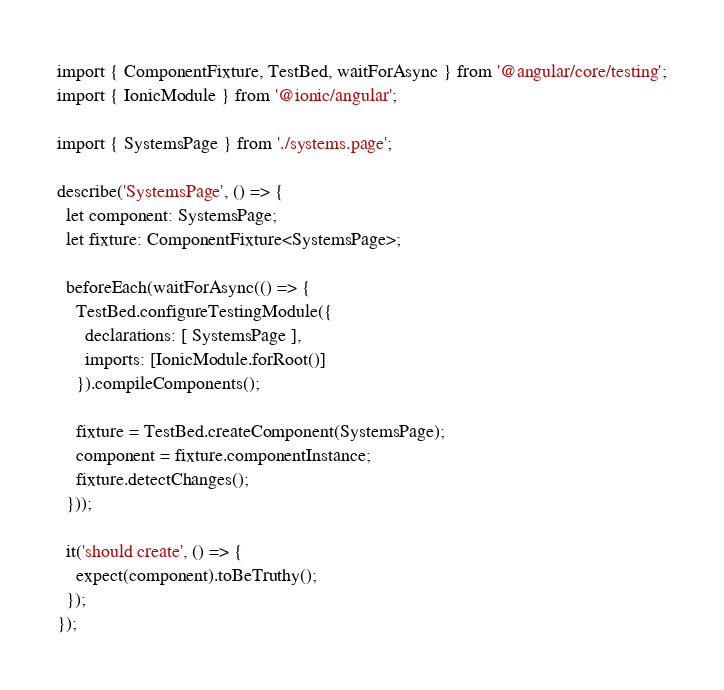Convert code to text. <code><loc_0><loc_0><loc_500><loc_500><_TypeScript_>import { ComponentFixture, TestBed, waitForAsync } from '@angular/core/testing';
import { IonicModule } from '@ionic/angular';

import { SystemsPage } from './systems.page';

describe('SystemsPage', () => {
  let component: SystemsPage;
  let fixture: ComponentFixture<SystemsPage>;

  beforeEach(waitForAsync(() => {
    TestBed.configureTestingModule({
      declarations: [ SystemsPage ],
      imports: [IonicModule.forRoot()]
    }).compileComponents();

    fixture = TestBed.createComponent(SystemsPage);
    component = fixture.componentInstance;
    fixture.detectChanges();
  }));

  it('should create', () => {
    expect(component).toBeTruthy();
  });
});
</code> 